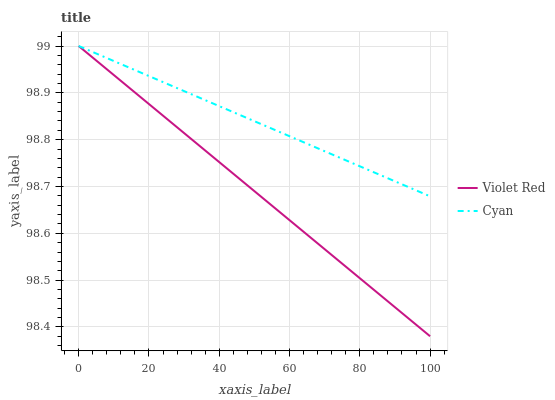Does Violet Red have the minimum area under the curve?
Answer yes or no. Yes. Does Cyan have the maximum area under the curve?
Answer yes or no. Yes. Does Violet Red have the maximum area under the curve?
Answer yes or no. No. Is Violet Red the smoothest?
Answer yes or no. Yes. Is Cyan the roughest?
Answer yes or no. Yes. Is Violet Red the roughest?
Answer yes or no. No. Does Violet Red have the lowest value?
Answer yes or no. Yes. Does Violet Red have the highest value?
Answer yes or no. Yes. Does Violet Red intersect Cyan?
Answer yes or no. Yes. Is Violet Red less than Cyan?
Answer yes or no. No. Is Violet Red greater than Cyan?
Answer yes or no. No. 